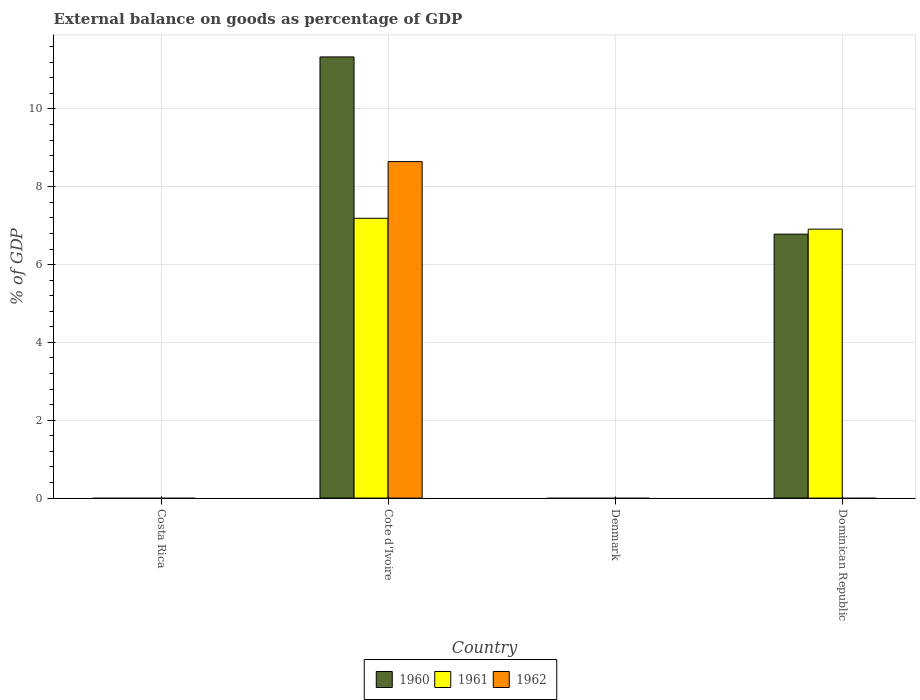How many different coloured bars are there?
Offer a terse response. 3. Are the number of bars per tick equal to the number of legend labels?
Your answer should be very brief. No. How many bars are there on the 4th tick from the right?
Keep it short and to the point. 0. What is the label of the 1st group of bars from the left?
Provide a succinct answer. Costa Rica. Across all countries, what is the maximum external balance on goods as percentage of GDP in 1961?
Offer a very short reply. 7.19. Across all countries, what is the minimum external balance on goods as percentage of GDP in 1962?
Offer a terse response. 0. In which country was the external balance on goods as percentage of GDP in 1962 maximum?
Your answer should be compact. Cote d'Ivoire. What is the total external balance on goods as percentage of GDP in 1960 in the graph?
Your response must be concise. 18.12. What is the difference between the external balance on goods as percentage of GDP in 1961 in Cote d'Ivoire and that in Dominican Republic?
Offer a very short reply. 0.28. What is the average external balance on goods as percentage of GDP in 1962 per country?
Ensure brevity in your answer.  2.16. What is the difference between the external balance on goods as percentage of GDP of/in 1961 and external balance on goods as percentage of GDP of/in 1960 in Cote d'Ivoire?
Ensure brevity in your answer.  -4.15. In how many countries, is the external balance on goods as percentage of GDP in 1961 greater than 7.2 %?
Your response must be concise. 0. What is the difference between the highest and the lowest external balance on goods as percentage of GDP in 1962?
Offer a very short reply. 8.65. In how many countries, is the external balance on goods as percentage of GDP in 1960 greater than the average external balance on goods as percentage of GDP in 1960 taken over all countries?
Your answer should be compact. 2. How many bars are there?
Provide a succinct answer. 5. What is the difference between two consecutive major ticks on the Y-axis?
Offer a very short reply. 2. Where does the legend appear in the graph?
Make the answer very short. Bottom center. How are the legend labels stacked?
Your answer should be very brief. Horizontal. What is the title of the graph?
Make the answer very short. External balance on goods as percentage of GDP. Does "1977" appear as one of the legend labels in the graph?
Give a very brief answer. No. What is the label or title of the X-axis?
Provide a short and direct response. Country. What is the label or title of the Y-axis?
Offer a terse response. % of GDP. What is the % of GDP of 1961 in Costa Rica?
Offer a very short reply. 0. What is the % of GDP in 1960 in Cote d'Ivoire?
Keep it short and to the point. 11.34. What is the % of GDP of 1961 in Cote d'Ivoire?
Make the answer very short. 7.19. What is the % of GDP in 1962 in Cote d'Ivoire?
Your response must be concise. 8.65. What is the % of GDP of 1961 in Denmark?
Your response must be concise. 0. What is the % of GDP in 1960 in Dominican Republic?
Ensure brevity in your answer.  6.78. What is the % of GDP in 1961 in Dominican Republic?
Offer a very short reply. 6.91. Across all countries, what is the maximum % of GDP in 1960?
Offer a very short reply. 11.34. Across all countries, what is the maximum % of GDP in 1961?
Offer a very short reply. 7.19. Across all countries, what is the maximum % of GDP of 1962?
Offer a very short reply. 8.65. Across all countries, what is the minimum % of GDP of 1961?
Give a very brief answer. 0. What is the total % of GDP in 1960 in the graph?
Ensure brevity in your answer.  18.12. What is the total % of GDP in 1961 in the graph?
Your response must be concise. 14.1. What is the total % of GDP in 1962 in the graph?
Your response must be concise. 8.65. What is the difference between the % of GDP of 1960 in Cote d'Ivoire and that in Dominican Republic?
Make the answer very short. 4.55. What is the difference between the % of GDP in 1961 in Cote d'Ivoire and that in Dominican Republic?
Give a very brief answer. 0.28. What is the difference between the % of GDP in 1960 in Cote d'Ivoire and the % of GDP in 1961 in Dominican Republic?
Your answer should be compact. 4.42. What is the average % of GDP of 1960 per country?
Give a very brief answer. 4.53. What is the average % of GDP of 1961 per country?
Your response must be concise. 3.52. What is the average % of GDP in 1962 per country?
Offer a terse response. 2.16. What is the difference between the % of GDP in 1960 and % of GDP in 1961 in Cote d'Ivoire?
Your answer should be very brief. 4.15. What is the difference between the % of GDP of 1960 and % of GDP of 1962 in Cote d'Ivoire?
Offer a very short reply. 2.69. What is the difference between the % of GDP of 1961 and % of GDP of 1962 in Cote d'Ivoire?
Your answer should be very brief. -1.46. What is the difference between the % of GDP in 1960 and % of GDP in 1961 in Dominican Republic?
Make the answer very short. -0.13. What is the ratio of the % of GDP of 1960 in Cote d'Ivoire to that in Dominican Republic?
Provide a succinct answer. 1.67. What is the ratio of the % of GDP in 1961 in Cote d'Ivoire to that in Dominican Republic?
Your answer should be compact. 1.04. What is the difference between the highest and the lowest % of GDP in 1960?
Provide a short and direct response. 11.34. What is the difference between the highest and the lowest % of GDP of 1961?
Provide a short and direct response. 7.19. What is the difference between the highest and the lowest % of GDP in 1962?
Provide a succinct answer. 8.65. 